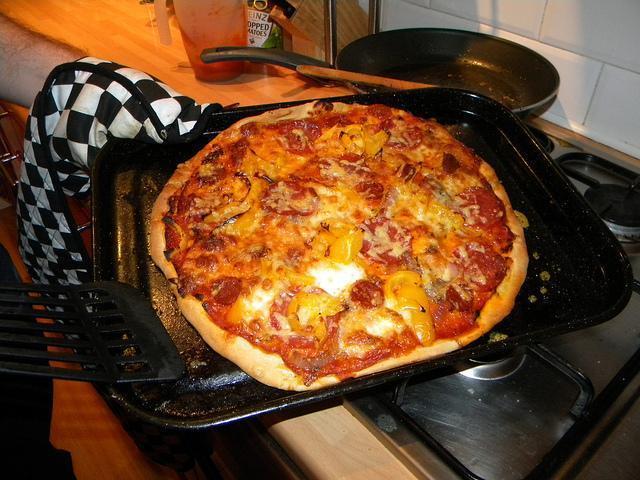How many pizzas can be seen?
Give a very brief answer. 1. 